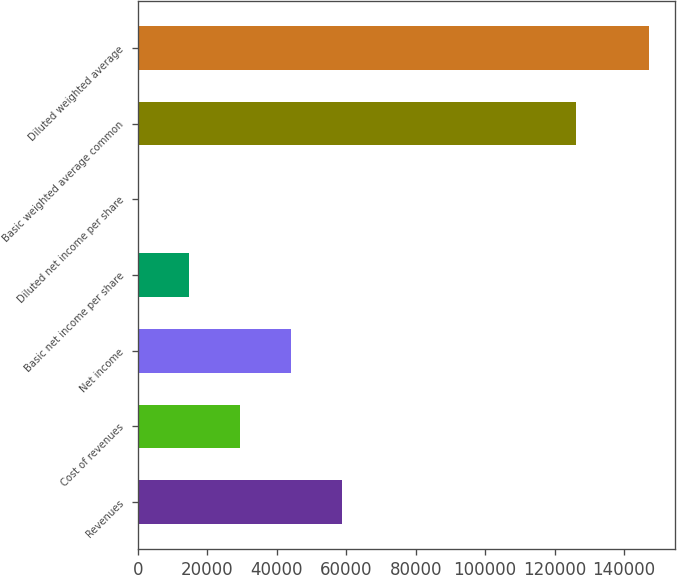<chart> <loc_0><loc_0><loc_500><loc_500><bar_chart><fcel>Revenues<fcel>Cost of revenues<fcel>Net income<fcel>Basic net income per share<fcel>Diluted net income per share<fcel>Basic weighted average common<fcel>Diluted weighted average<nl><fcel>58922.5<fcel>29461.3<fcel>44191.9<fcel>14730.7<fcel>0.1<fcel>126261<fcel>147306<nl></chart> 